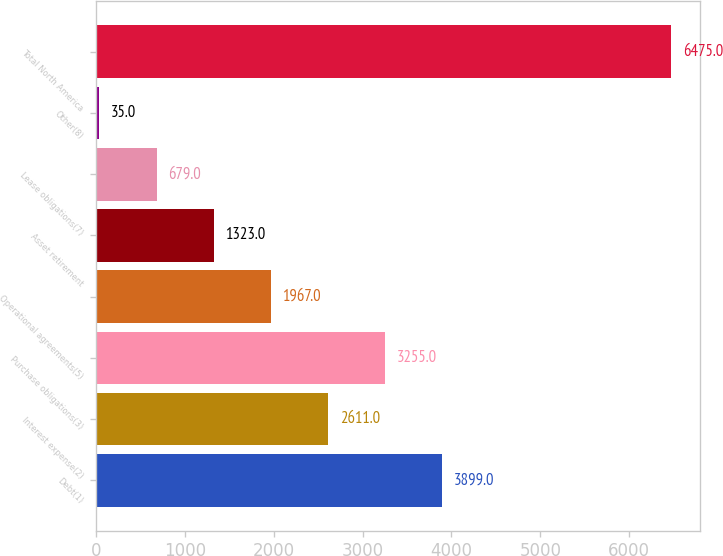Convert chart. <chart><loc_0><loc_0><loc_500><loc_500><bar_chart><fcel>Debt(1)<fcel>Interest expense(2)<fcel>Purchase obligations(3)<fcel>Operational agreements(5)<fcel>Asset retirement<fcel>Lease obligations(7)<fcel>Other(8)<fcel>Total North America<nl><fcel>3899<fcel>2611<fcel>3255<fcel>1967<fcel>1323<fcel>679<fcel>35<fcel>6475<nl></chart> 